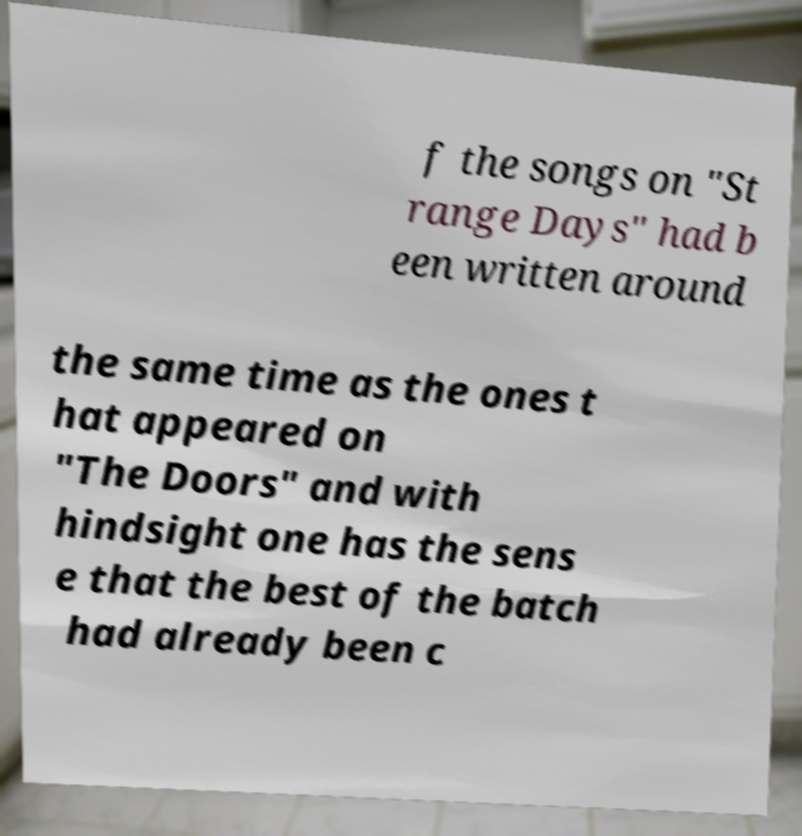Please identify and transcribe the text found in this image. f the songs on "St range Days" had b een written around the same time as the ones t hat appeared on "The Doors" and with hindsight one has the sens e that the best of the batch had already been c 